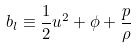<formula> <loc_0><loc_0><loc_500><loc_500>b _ { l } \equiv \frac { 1 } { 2 } u ^ { 2 } + \phi + \frac { p } { \rho }</formula> 